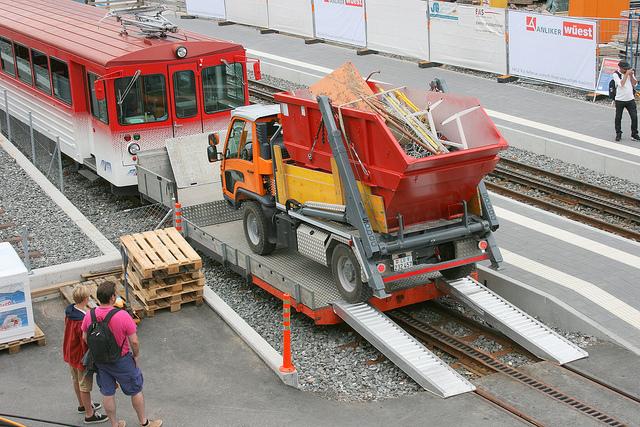How many people are in the image?
Give a very brief answer. 3. Is this train currently functional?
Give a very brief answer. No. How many pallets are there?
Keep it brief. 7. 